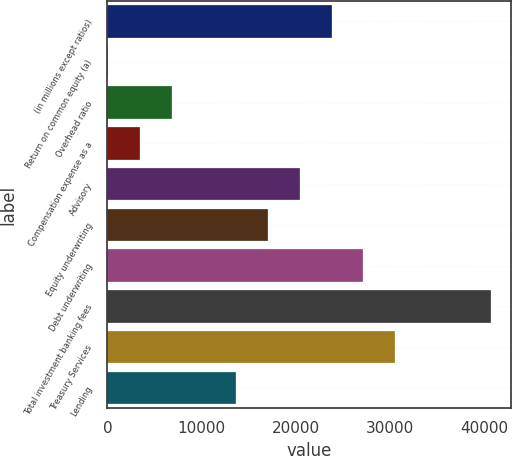<chart> <loc_0><loc_0><loc_500><loc_500><bar_chart><fcel>(in millions except ratios)<fcel>Return on common equity (a)<fcel>Overhead ratio<fcel>Compensation expense as a<fcel>Advisory<fcel>Equity underwriting<fcel>Debt underwriting<fcel>Total investment banking fees<fcel>Treasury Services<fcel>Lending<nl><fcel>23793.9<fcel>17<fcel>6810.4<fcel>3413.7<fcel>20397.2<fcel>17000.5<fcel>27190.6<fcel>40777.4<fcel>30587.3<fcel>13603.8<nl></chart> 